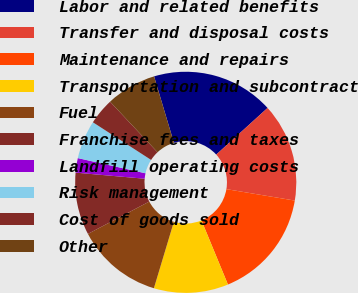Convert chart to OTSL. <chart><loc_0><loc_0><loc_500><loc_500><pie_chart><fcel>Labor and related benefits<fcel>Transfer and disposal costs<fcel>Maintenance and repairs<fcel>Transportation and subcontract<fcel>Fuel<fcel>Franchise fees and taxes<fcel>Landfill operating costs<fcel>Risk management<fcel>Cost of goods sold<fcel>Other<nl><fcel>17.88%<fcel>14.38%<fcel>16.13%<fcel>10.88%<fcel>12.63%<fcel>9.12%<fcel>2.12%<fcel>5.62%<fcel>3.87%<fcel>7.37%<nl></chart> 